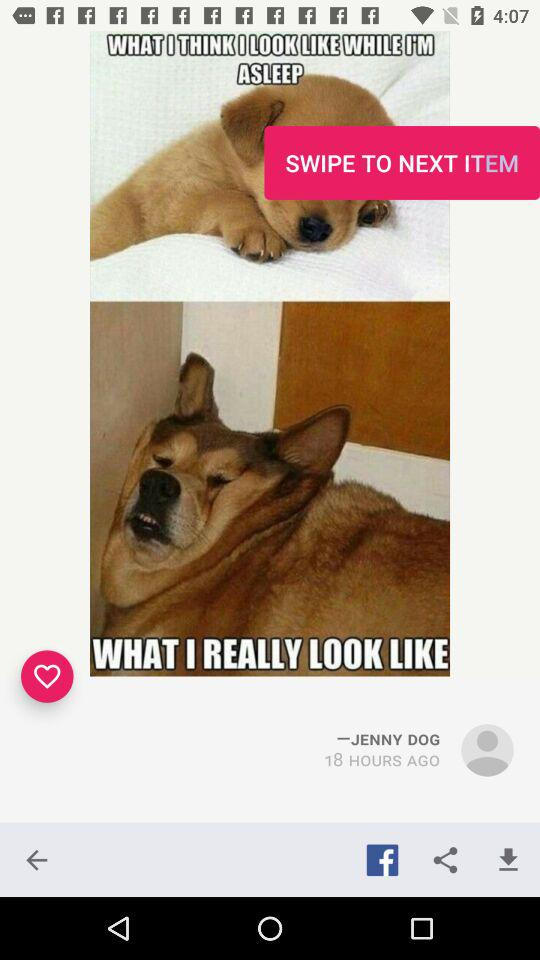How many hours ago did Jenny Dog post the post? Jenny Dog posted the post 18 hours ago. 